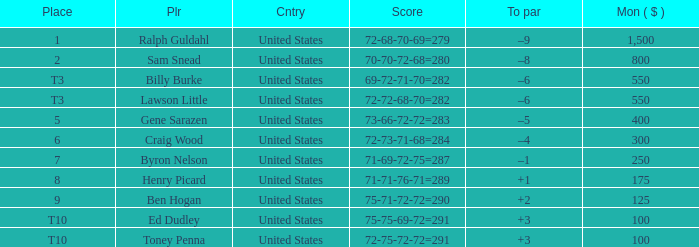Which score has a prize of $400? 73-66-72-72=283. 